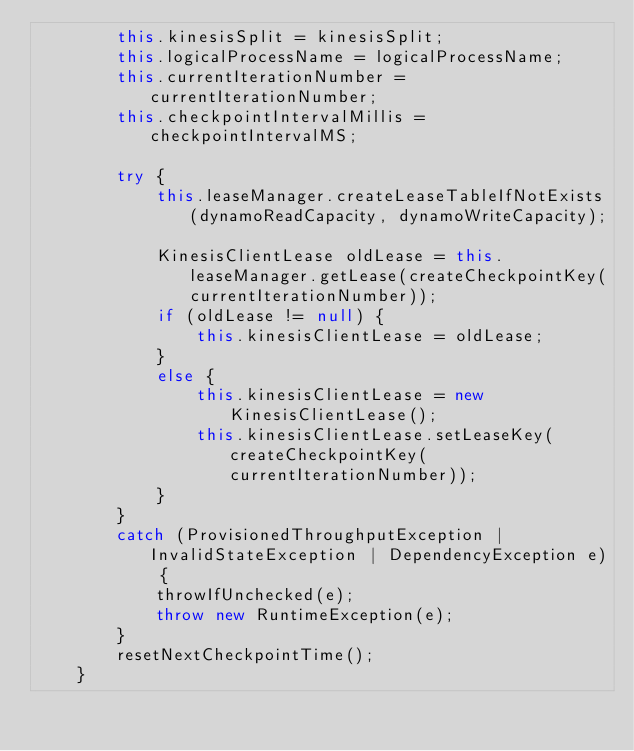Convert code to text. <code><loc_0><loc_0><loc_500><loc_500><_Java_>        this.kinesisSplit = kinesisSplit;
        this.logicalProcessName = logicalProcessName;
        this.currentIterationNumber = currentIterationNumber;
        this.checkpointIntervalMillis = checkpointIntervalMS;

        try {
            this.leaseManager.createLeaseTableIfNotExists(dynamoReadCapacity, dynamoWriteCapacity);

            KinesisClientLease oldLease = this.leaseManager.getLease(createCheckpointKey(currentIterationNumber));
            if (oldLease != null) {
                this.kinesisClientLease = oldLease;
            }
            else {
                this.kinesisClientLease = new KinesisClientLease();
                this.kinesisClientLease.setLeaseKey(createCheckpointKey(currentIterationNumber));
            }
        }
        catch (ProvisionedThroughputException | InvalidStateException | DependencyException e) {
            throwIfUnchecked(e);
            throw new RuntimeException(e);
        }
        resetNextCheckpointTime();
    }
</code> 